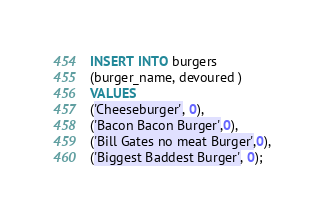<code> <loc_0><loc_0><loc_500><loc_500><_SQL_>INSERT INTO burgers
(burger_name, devoured )
VALUES
('Cheeseburger', 0),
('Bacon Bacon Burger',0),
('Bill Gates no meat Burger',0),
('Biggest Baddest Burger', 0);

</code> 